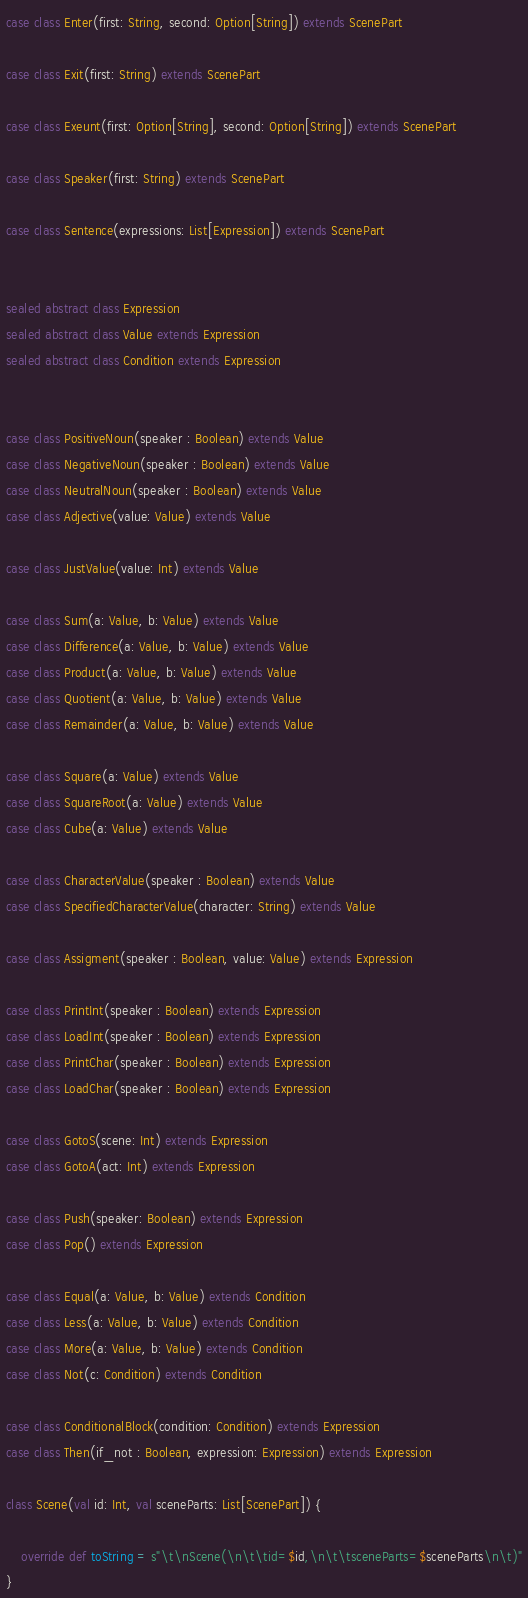<code> <loc_0><loc_0><loc_500><loc_500><_Scala_>case class Enter(first: String, second: Option[String]) extends ScenePart

case class Exit(first: String) extends ScenePart

case class Exeunt(first: Option[String], second: Option[String]) extends ScenePart

case class Speaker(first: String) extends ScenePart

case class Sentence(expressions: List[Expression]) extends ScenePart


sealed abstract class Expression
sealed abstract class Value extends Expression
sealed abstract class Condition extends Expression


case class PositiveNoun(speaker : Boolean) extends Value
case class NegativeNoun(speaker : Boolean) extends Value
case class NeutralNoun(speaker : Boolean) extends Value
case class Adjective(value: Value) extends Value

case class JustValue(value: Int) extends Value

case class Sum(a: Value, b: Value) extends Value
case class Difference(a: Value, b: Value) extends Value
case class Product(a: Value, b: Value) extends Value
case class Quotient(a: Value, b: Value) extends Value
case class Remainder(a: Value, b: Value) extends Value

case class Square(a: Value) extends Value
case class SquareRoot(a: Value) extends Value
case class Cube(a: Value) extends Value

case class CharacterValue(speaker : Boolean) extends Value
case class SpecifiedCharacterValue(character: String) extends Value

case class Assigment(speaker : Boolean, value: Value) extends Expression

case class PrintInt(speaker : Boolean) extends Expression
case class LoadInt(speaker : Boolean) extends Expression
case class PrintChar(speaker : Boolean) extends Expression
case class LoadChar(speaker : Boolean) extends Expression

case class GotoS(scene: Int) extends Expression
case class GotoA(act: Int) extends Expression

case class Push(speaker: Boolean) extends Expression
case class Pop() extends Expression

case class Equal(a: Value, b: Value) extends Condition
case class Less(a: Value, b: Value) extends Condition
case class More(a: Value, b: Value) extends Condition
case class Not(c: Condition) extends Condition

case class ConditionalBlock(condition: Condition) extends Expression
case class Then(if_not : Boolean, expression: Expression) extends Expression

class Scene(val id: Int, val sceneParts: List[ScenePart]) {

    override def toString = s"\t\nScene(\n\t\tid=$id,\n\t\tsceneParts=$sceneParts\n\t)"
}
</code> 